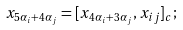<formula> <loc_0><loc_0><loc_500><loc_500>x _ { 5 \alpha _ { i } + 4 \alpha _ { j } } = [ x _ { 4 \alpha _ { i } + 3 \alpha _ { j } } , x _ { i j } ] _ { c } ;</formula> 